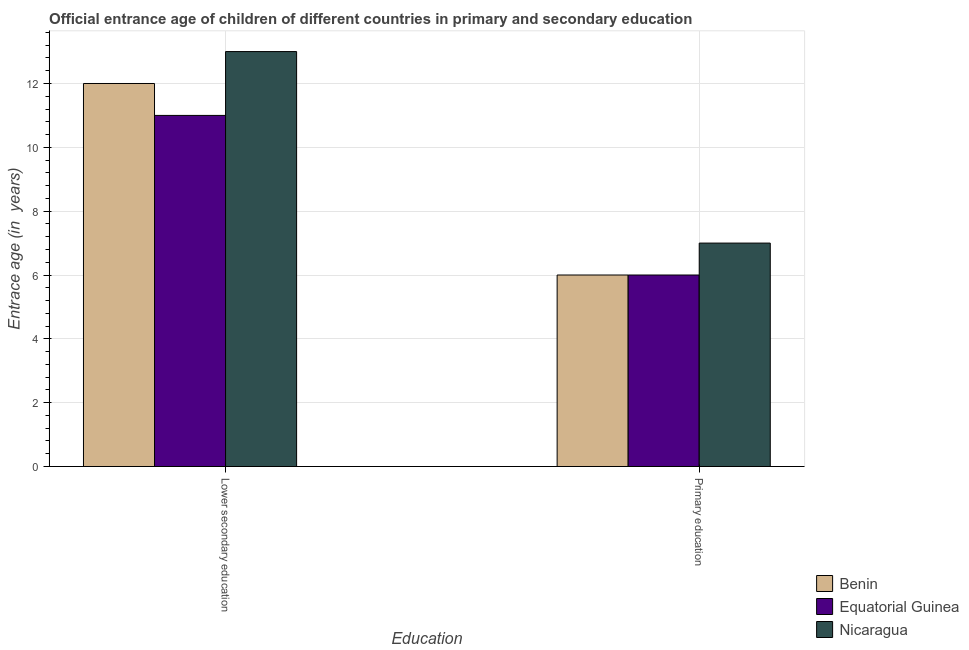Are the number of bars on each tick of the X-axis equal?
Ensure brevity in your answer.  Yes. How many bars are there on the 2nd tick from the left?
Give a very brief answer. 3. How many bars are there on the 2nd tick from the right?
Offer a very short reply. 3. What is the label of the 2nd group of bars from the left?
Make the answer very short. Primary education. Across all countries, what is the maximum entrance age of chiildren in primary education?
Offer a very short reply. 7. In which country was the entrance age of chiildren in primary education maximum?
Keep it short and to the point. Nicaragua. In which country was the entrance age of chiildren in primary education minimum?
Provide a short and direct response. Benin. What is the total entrance age of children in lower secondary education in the graph?
Provide a succinct answer. 36. What is the difference between the entrance age of children in lower secondary education in Nicaragua and that in Equatorial Guinea?
Ensure brevity in your answer.  2. What is the difference between the entrance age of chiildren in primary education in Equatorial Guinea and the entrance age of children in lower secondary education in Nicaragua?
Provide a succinct answer. -7. In how many countries, is the entrance age of children in lower secondary education greater than 5.2 years?
Ensure brevity in your answer.  3. What is the ratio of the entrance age of children in lower secondary education in Equatorial Guinea to that in Nicaragua?
Your answer should be compact. 0.85. Is the entrance age of chiildren in primary education in Benin less than that in Equatorial Guinea?
Offer a terse response. No. In how many countries, is the entrance age of chiildren in primary education greater than the average entrance age of chiildren in primary education taken over all countries?
Your answer should be compact. 1. What does the 1st bar from the left in Primary education represents?
Provide a succinct answer. Benin. What does the 2nd bar from the right in Lower secondary education represents?
Your response must be concise. Equatorial Guinea. Are all the bars in the graph horizontal?
Offer a terse response. No. How many countries are there in the graph?
Provide a succinct answer. 3. What is the difference between two consecutive major ticks on the Y-axis?
Your response must be concise. 2. Does the graph contain any zero values?
Make the answer very short. No. How many legend labels are there?
Offer a very short reply. 3. How are the legend labels stacked?
Offer a terse response. Vertical. What is the title of the graph?
Provide a short and direct response. Official entrance age of children of different countries in primary and secondary education. What is the label or title of the X-axis?
Your answer should be compact. Education. What is the label or title of the Y-axis?
Your response must be concise. Entrace age (in  years). What is the Entrace age (in  years) in Benin in Primary education?
Provide a short and direct response. 6. What is the Entrace age (in  years) of Equatorial Guinea in Primary education?
Your response must be concise. 6. What is the Entrace age (in  years) of Nicaragua in Primary education?
Offer a terse response. 7. Across all Education, what is the maximum Entrace age (in  years) of Nicaragua?
Your response must be concise. 13. Across all Education, what is the minimum Entrace age (in  years) of Benin?
Give a very brief answer. 6. What is the total Entrace age (in  years) in Benin in the graph?
Your answer should be compact. 18. What is the total Entrace age (in  years) in Nicaragua in the graph?
Your answer should be very brief. 20. What is the difference between the Entrace age (in  years) in Benin in Lower secondary education and that in Primary education?
Your answer should be compact. 6. What is the difference between the Entrace age (in  years) in Equatorial Guinea in Lower secondary education and that in Primary education?
Your answer should be compact. 5. What is the difference between the Entrace age (in  years) of Benin in Lower secondary education and the Entrace age (in  years) of Equatorial Guinea in Primary education?
Ensure brevity in your answer.  6. What is the difference between the Entrace age (in  years) in Benin in Lower secondary education and the Entrace age (in  years) in Nicaragua in Primary education?
Keep it short and to the point. 5. What is the average Entrace age (in  years) in Nicaragua per Education?
Your answer should be compact. 10. What is the difference between the Entrace age (in  years) in Benin and Entrace age (in  years) in Nicaragua in Primary education?
Offer a very short reply. -1. What is the difference between the Entrace age (in  years) in Equatorial Guinea and Entrace age (in  years) in Nicaragua in Primary education?
Your response must be concise. -1. What is the ratio of the Entrace age (in  years) of Benin in Lower secondary education to that in Primary education?
Your answer should be very brief. 2. What is the ratio of the Entrace age (in  years) of Equatorial Guinea in Lower secondary education to that in Primary education?
Provide a succinct answer. 1.83. What is the ratio of the Entrace age (in  years) of Nicaragua in Lower secondary education to that in Primary education?
Ensure brevity in your answer.  1.86. What is the difference between the highest and the second highest Entrace age (in  years) of Equatorial Guinea?
Provide a short and direct response. 5. What is the difference between the highest and the second highest Entrace age (in  years) of Nicaragua?
Your answer should be very brief. 6. What is the difference between the highest and the lowest Entrace age (in  years) in Equatorial Guinea?
Your answer should be compact. 5. 